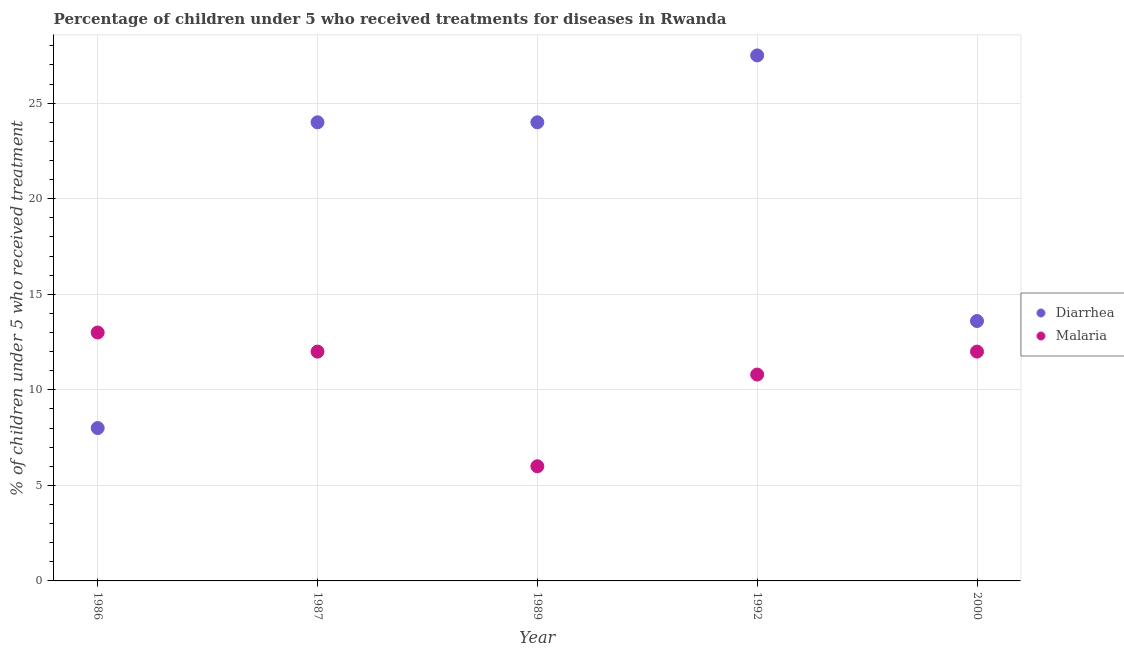What is the percentage of children who received treatment for malaria in 2000?
Provide a succinct answer. 12. Across all years, what is the maximum percentage of children who received treatment for diarrhoea?
Your response must be concise. 27.5. Across all years, what is the minimum percentage of children who received treatment for diarrhoea?
Make the answer very short. 8. What is the total percentage of children who received treatment for malaria in the graph?
Keep it short and to the point. 53.8. What is the difference between the percentage of children who received treatment for diarrhoea in 2000 and the percentage of children who received treatment for malaria in 1992?
Ensure brevity in your answer.  2.8. What is the average percentage of children who received treatment for diarrhoea per year?
Give a very brief answer. 19.42. In how many years, is the percentage of children who received treatment for malaria greater than 4 %?
Provide a short and direct response. 5. What is the ratio of the percentage of children who received treatment for diarrhoea in 1986 to that in 1987?
Make the answer very short. 0.33. Is the difference between the percentage of children who received treatment for diarrhoea in 1987 and 2000 greater than the difference between the percentage of children who received treatment for malaria in 1987 and 2000?
Make the answer very short. Yes. Does the percentage of children who received treatment for malaria monotonically increase over the years?
Your answer should be very brief. No. Is the percentage of children who received treatment for malaria strictly greater than the percentage of children who received treatment for diarrhoea over the years?
Provide a succinct answer. No. How many dotlines are there?
Provide a short and direct response. 2. How many years are there in the graph?
Ensure brevity in your answer.  5. What is the difference between two consecutive major ticks on the Y-axis?
Ensure brevity in your answer.  5. Does the graph contain any zero values?
Provide a succinct answer. No. Does the graph contain grids?
Provide a succinct answer. Yes. How are the legend labels stacked?
Ensure brevity in your answer.  Vertical. What is the title of the graph?
Give a very brief answer. Percentage of children under 5 who received treatments for diseases in Rwanda. Does "Non-resident workers" appear as one of the legend labels in the graph?
Ensure brevity in your answer.  No. What is the label or title of the X-axis?
Give a very brief answer. Year. What is the label or title of the Y-axis?
Your response must be concise. % of children under 5 who received treatment. What is the % of children under 5 who received treatment of Diarrhea in 1986?
Provide a short and direct response. 8. What is the % of children under 5 who received treatment in Diarrhea in 1989?
Give a very brief answer. 24. What is the % of children under 5 who received treatment in Malaria in 1989?
Your answer should be very brief. 6. What is the % of children under 5 who received treatment of Diarrhea in 1992?
Ensure brevity in your answer.  27.5. What is the % of children under 5 who received treatment in Malaria in 1992?
Keep it short and to the point. 10.8. What is the % of children under 5 who received treatment of Malaria in 2000?
Give a very brief answer. 12. Across all years, what is the maximum % of children under 5 who received treatment of Malaria?
Provide a succinct answer. 13. What is the total % of children under 5 who received treatment in Diarrhea in the graph?
Make the answer very short. 97.1. What is the total % of children under 5 who received treatment of Malaria in the graph?
Give a very brief answer. 53.8. What is the difference between the % of children under 5 who received treatment of Malaria in 1986 and that in 1987?
Your response must be concise. 1. What is the difference between the % of children under 5 who received treatment of Diarrhea in 1986 and that in 1989?
Make the answer very short. -16. What is the difference between the % of children under 5 who received treatment of Diarrhea in 1986 and that in 1992?
Provide a short and direct response. -19.5. What is the difference between the % of children under 5 who received treatment of Malaria in 1986 and that in 1992?
Your response must be concise. 2.2. What is the difference between the % of children under 5 who received treatment of Diarrhea in 1986 and that in 2000?
Offer a very short reply. -5.6. What is the difference between the % of children under 5 who received treatment in Diarrhea in 1987 and that in 1989?
Make the answer very short. 0. What is the difference between the % of children under 5 who received treatment in Malaria in 1987 and that in 1989?
Keep it short and to the point. 6. What is the difference between the % of children under 5 who received treatment of Malaria in 1987 and that in 1992?
Provide a succinct answer. 1.2. What is the difference between the % of children under 5 who received treatment of Diarrhea in 1989 and that in 1992?
Keep it short and to the point. -3.5. What is the difference between the % of children under 5 who received treatment in Malaria in 1989 and that in 1992?
Offer a very short reply. -4.8. What is the difference between the % of children under 5 who received treatment of Diarrhea in 1989 and that in 2000?
Your answer should be compact. 10.4. What is the difference between the % of children under 5 who received treatment in Malaria in 1989 and that in 2000?
Make the answer very short. -6. What is the difference between the % of children under 5 who received treatment of Malaria in 1992 and that in 2000?
Provide a succinct answer. -1.2. What is the difference between the % of children under 5 who received treatment in Diarrhea in 1986 and the % of children under 5 who received treatment in Malaria in 1989?
Provide a short and direct response. 2. What is the difference between the % of children under 5 who received treatment of Diarrhea in 1986 and the % of children under 5 who received treatment of Malaria in 1992?
Make the answer very short. -2.8. What is the difference between the % of children under 5 who received treatment of Diarrhea in 1986 and the % of children under 5 who received treatment of Malaria in 2000?
Give a very brief answer. -4. What is the difference between the % of children under 5 who received treatment in Diarrhea in 1987 and the % of children under 5 who received treatment in Malaria in 2000?
Your answer should be very brief. 12. What is the difference between the % of children under 5 who received treatment in Diarrhea in 1989 and the % of children under 5 who received treatment in Malaria in 1992?
Your answer should be compact. 13.2. What is the difference between the % of children under 5 who received treatment in Diarrhea in 1989 and the % of children under 5 who received treatment in Malaria in 2000?
Keep it short and to the point. 12. What is the average % of children under 5 who received treatment in Diarrhea per year?
Ensure brevity in your answer.  19.42. What is the average % of children under 5 who received treatment in Malaria per year?
Keep it short and to the point. 10.76. What is the ratio of the % of children under 5 who received treatment of Malaria in 1986 to that in 1987?
Ensure brevity in your answer.  1.08. What is the ratio of the % of children under 5 who received treatment of Diarrhea in 1986 to that in 1989?
Keep it short and to the point. 0.33. What is the ratio of the % of children under 5 who received treatment in Malaria in 1986 to that in 1989?
Provide a succinct answer. 2.17. What is the ratio of the % of children under 5 who received treatment in Diarrhea in 1986 to that in 1992?
Make the answer very short. 0.29. What is the ratio of the % of children under 5 who received treatment in Malaria in 1986 to that in 1992?
Offer a terse response. 1.2. What is the ratio of the % of children under 5 who received treatment in Diarrhea in 1986 to that in 2000?
Your response must be concise. 0.59. What is the ratio of the % of children under 5 who received treatment of Diarrhea in 1987 to that in 1992?
Ensure brevity in your answer.  0.87. What is the ratio of the % of children under 5 who received treatment in Diarrhea in 1987 to that in 2000?
Offer a terse response. 1.76. What is the ratio of the % of children under 5 who received treatment in Diarrhea in 1989 to that in 1992?
Your response must be concise. 0.87. What is the ratio of the % of children under 5 who received treatment in Malaria in 1989 to that in 1992?
Your answer should be compact. 0.56. What is the ratio of the % of children under 5 who received treatment of Diarrhea in 1989 to that in 2000?
Provide a short and direct response. 1.76. What is the ratio of the % of children under 5 who received treatment in Diarrhea in 1992 to that in 2000?
Your response must be concise. 2.02. What is the ratio of the % of children under 5 who received treatment of Malaria in 1992 to that in 2000?
Make the answer very short. 0.9. What is the difference between the highest and the second highest % of children under 5 who received treatment of Diarrhea?
Your answer should be compact. 3.5. 